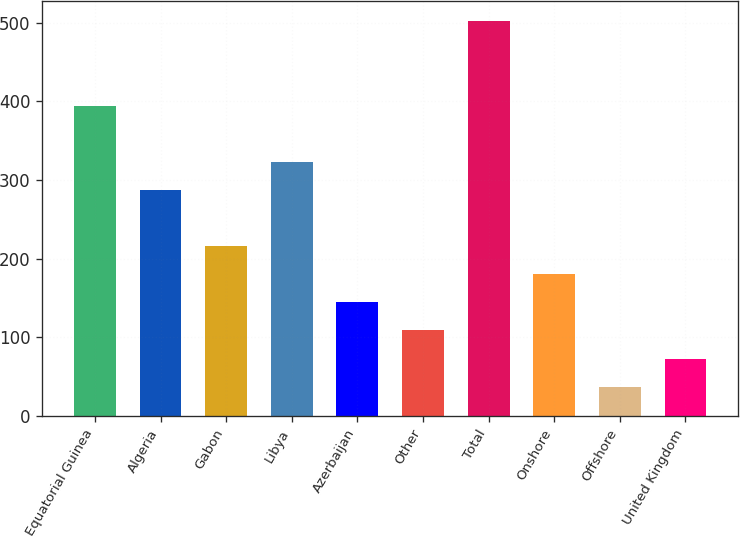Convert chart. <chart><loc_0><loc_0><loc_500><loc_500><bar_chart><fcel>Equatorial Guinea<fcel>Algeria<fcel>Gabon<fcel>Libya<fcel>Azerbaijan<fcel>Other<fcel>Total<fcel>Onshore<fcel>Offshore<fcel>United Kingdom<nl><fcel>394.8<fcel>287.4<fcel>215.8<fcel>323.2<fcel>144.2<fcel>108.4<fcel>502.2<fcel>180<fcel>36.8<fcel>72.6<nl></chart> 